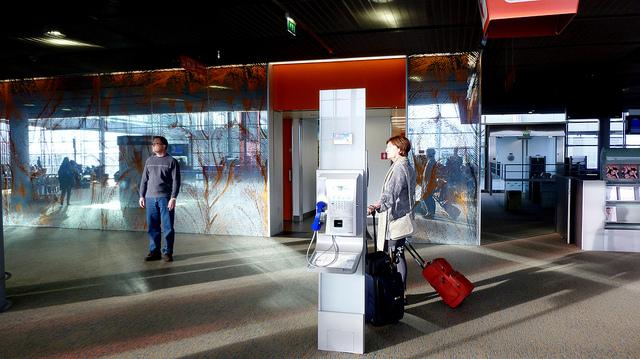Where is this?
Write a very short answer. Airport. What design is on the glass?
Answer briefly. Trees. What color is the woman's suitcase?
Write a very short answer. Red. 